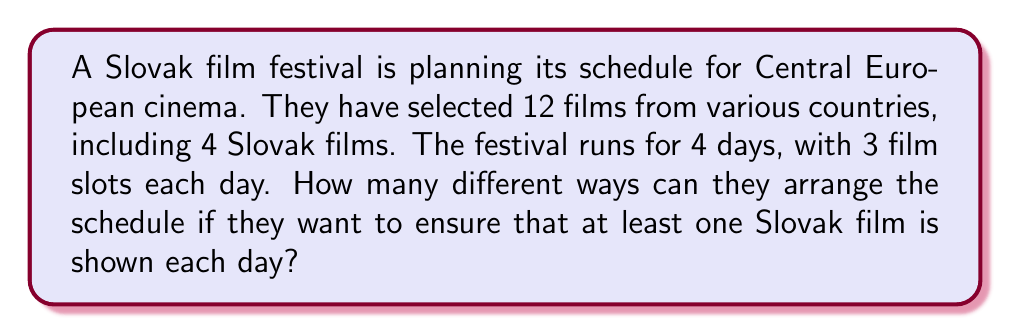Show me your answer to this math problem. Let's approach this step-by-step:

1) First, we need to select one Slovak film for each day to ensure the requirement is met. This can be done in $4 \times 3 \times 2 \times 1 = 24$ ways.

2) Now, we have 8 remaining slots to fill with the remaining 8 films (8 = 12 - 4).

3) To fill these 8 slots, we can use the combination formula:

   $$\binom{8}{8} = \frac{8!}{8!(8-8)!} = 1$$

4) For each of these combinations, we need to consider the number of permutations:

   $$8! = 40,320$$

5) Now, for each day, we need to arrange 3 films (the pre-selected Slovak film and 2 others). This can be done in $3!$ ways for each day.

   $$(3!)^4 = 1,296$$

6) Applying the multiplication principle, the total number of possible schedules is:

   $$24 \times 1 \times 40,320 \times 1,296 = 1,254,113,280$$

Thus, there are 1,254,113,280 different ways to arrange the schedule.
Answer: 1,254,113,280 